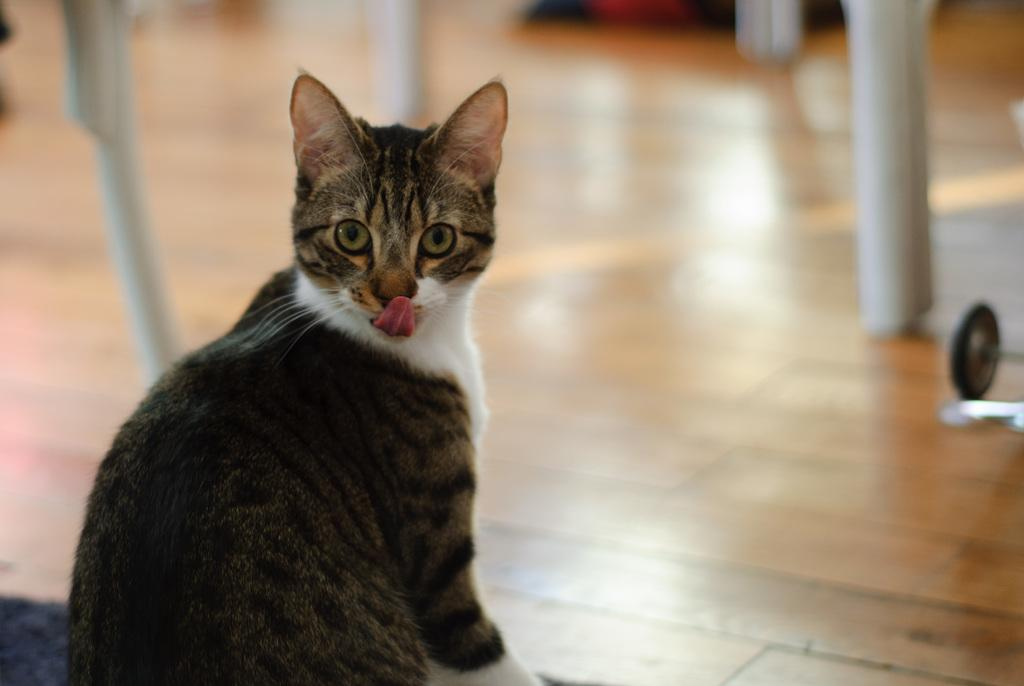What animal is present in the image? There is a cat in the image. Where is the cat located in the image? The cat is sitting on the floor. What is the cat doing in the image? The cat has its tongue out. Can you describe the background of the image? The background of the image is blurred. What word is being spoken by the cat in the image? Cats do not speak words, so there is no word being spoken by the cat in the image. 